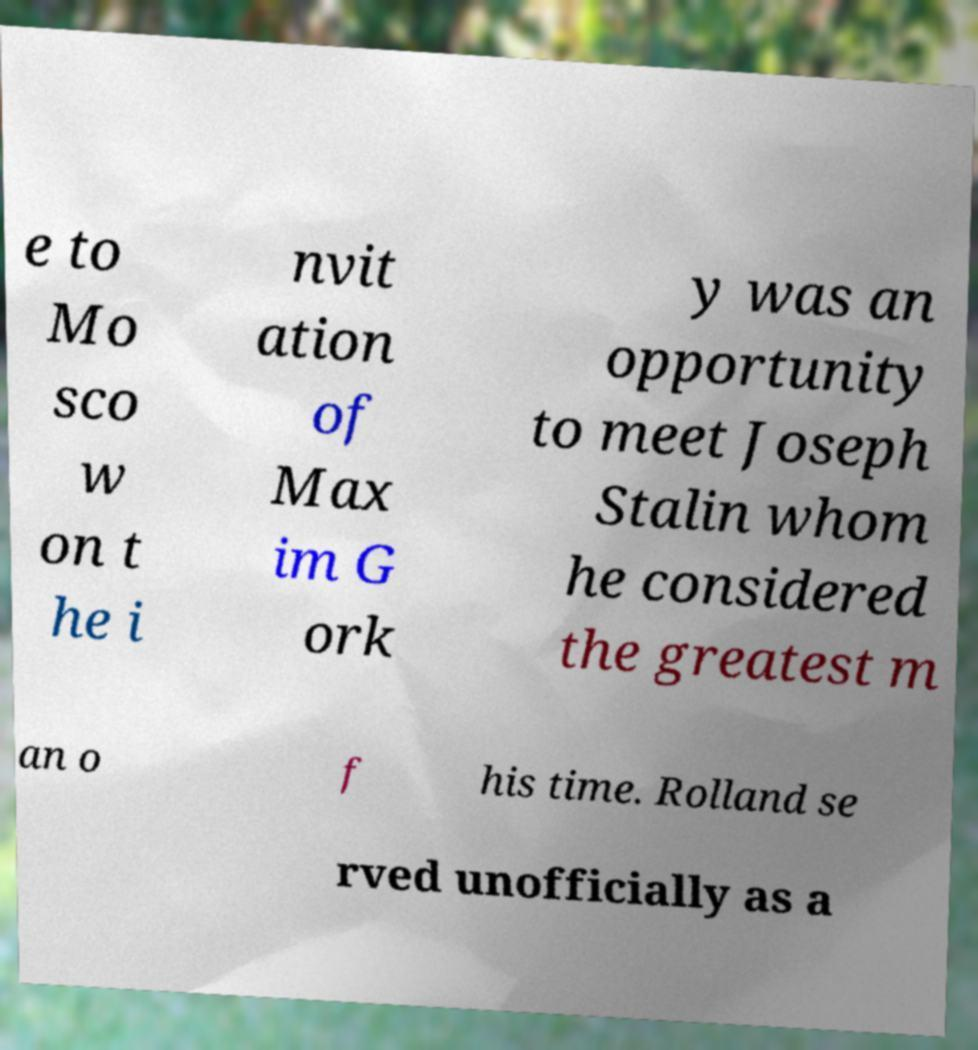There's text embedded in this image that I need extracted. Can you transcribe it verbatim? e to Mo sco w on t he i nvit ation of Max im G ork y was an opportunity to meet Joseph Stalin whom he considered the greatest m an o f his time. Rolland se rved unofficially as a 